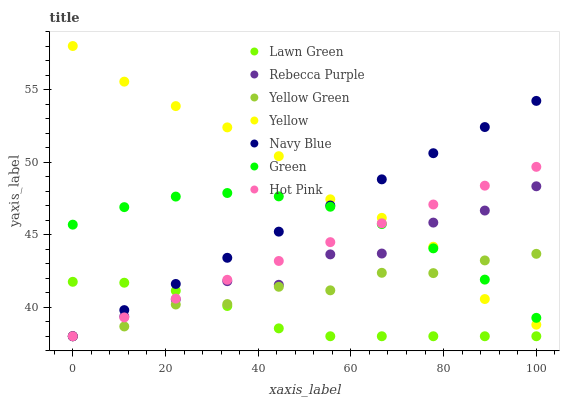Does Lawn Green have the minimum area under the curve?
Answer yes or no. Yes. Does Yellow have the maximum area under the curve?
Answer yes or no. Yes. Does Yellow Green have the minimum area under the curve?
Answer yes or no. No. Does Yellow Green have the maximum area under the curve?
Answer yes or no. No. Is Navy Blue the smoothest?
Answer yes or no. Yes. Is Rebecca Purple the roughest?
Answer yes or no. Yes. Is Yellow Green the smoothest?
Answer yes or no. No. Is Yellow Green the roughest?
Answer yes or no. No. Does Lawn Green have the lowest value?
Answer yes or no. Yes. Does Yellow have the lowest value?
Answer yes or no. No. Does Yellow have the highest value?
Answer yes or no. Yes. Does Yellow Green have the highest value?
Answer yes or no. No. Is Lawn Green less than Green?
Answer yes or no. Yes. Is Yellow greater than Lawn Green?
Answer yes or no. Yes. Does Yellow Green intersect Navy Blue?
Answer yes or no. Yes. Is Yellow Green less than Navy Blue?
Answer yes or no. No. Is Yellow Green greater than Navy Blue?
Answer yes or no. No. Does Lawn Green intersect Green?
Answer yes or no. No. 